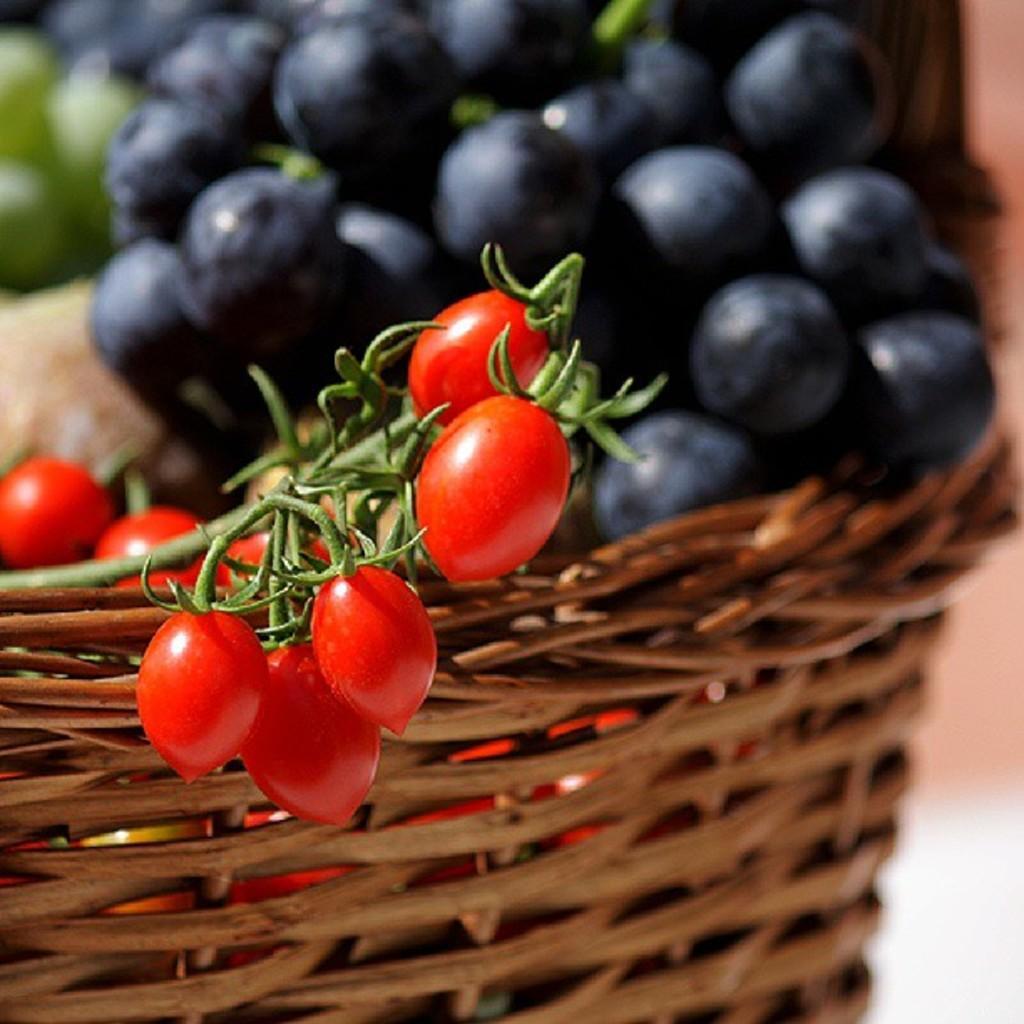Please provide a concise description of this image. In this in front cherries, blueberries and grapes in a basket. 